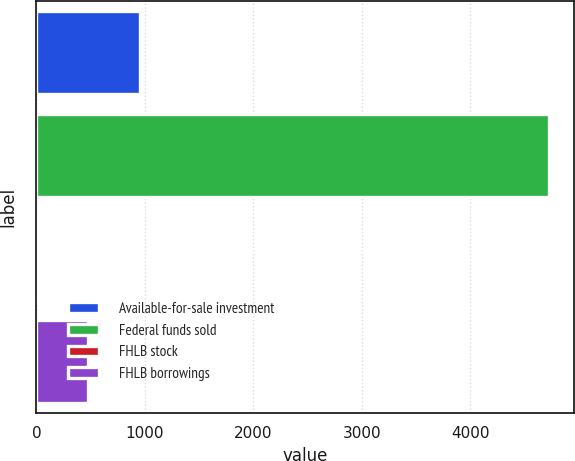<chart> <loc_0><loc_0><loc_500><loc_500><bar_chart><fcel>Available-for-sale investment<fcel>Federal funds sold<fcel>FHLB stock<fcel>FHLB borrowings<nl><fcel>951.2<fcel>4720<fcel>9<fcel>480.1<nl></chart> 